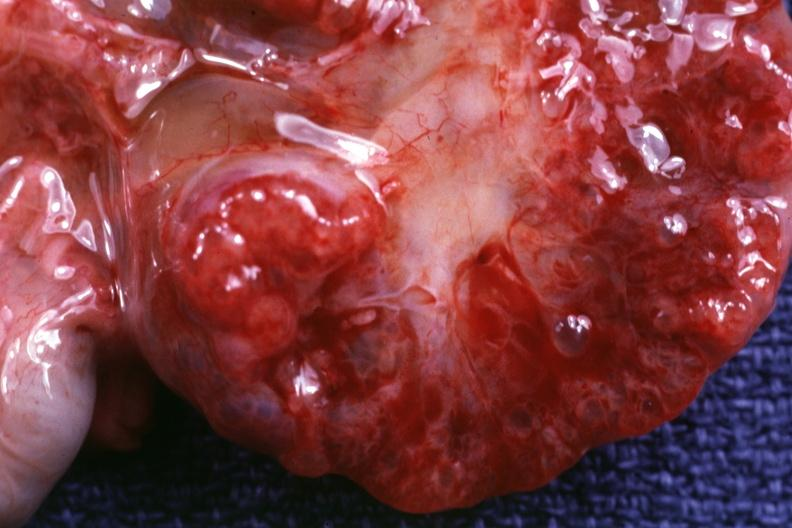what is present?
Answer the question using a single word or phrase. Kidney 